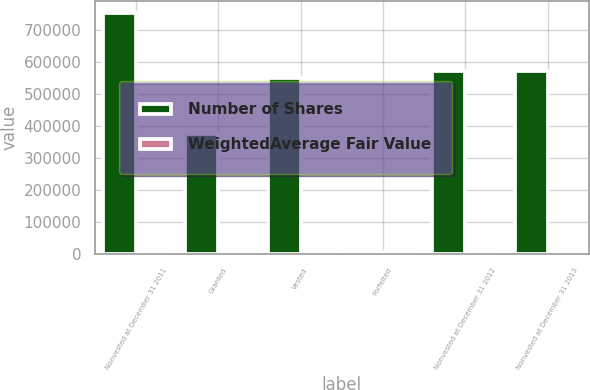<chart> <loc_0><loc_0><loc_500><loc_500><stacked_bar_chart><ecel><fcel>Nonvested at December 31 2011<fcel>Granted<fcel>Vested<fcel>Forfeited<fcel>Nonvested at December 31 2012<fcel>Nonvested at December 31 2013<nl><fcel>Number of Shares<fcel>753811<fcel>374307<fcel>551051<fcel>5162<fcel>571905<fcel>573850<nl><fcel>WeightedAverage Fair Value<fcel>61.15<fcel>95.78<fcel>64.59<fcel>70.56<fcel>80.96<fcel>103.44<nl></chart> 